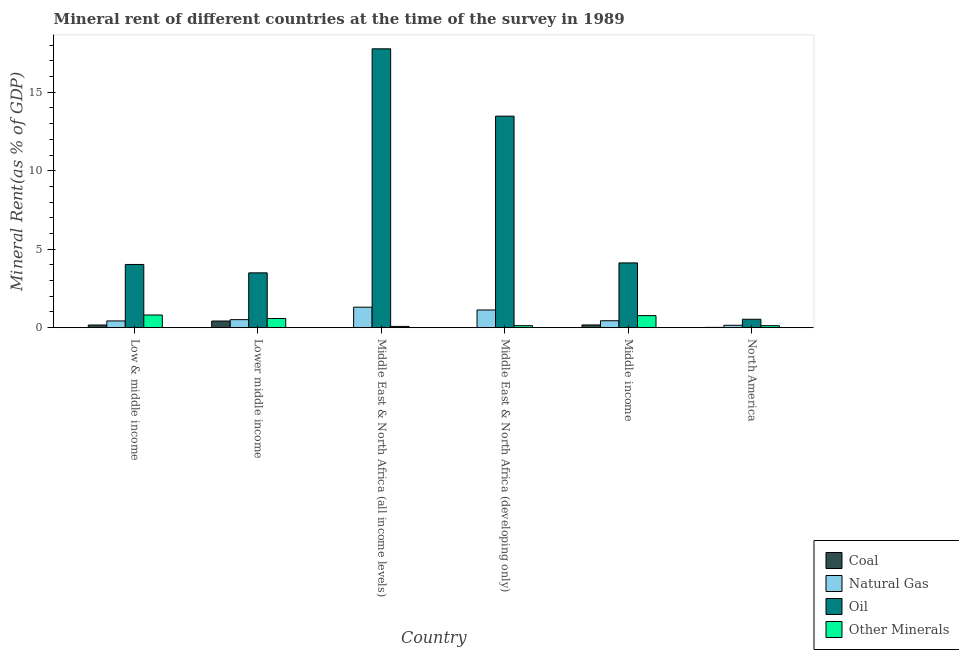Are the number of bars per tick equal to the number of legend labels?
Make the answer very short. Yes. Are the number of bars on each tick of the X-axis equal?
Make the answer very short. Yes. How many bars are there on the 6th tick from the left?
Your answer should be compact. 4. What is the label of the 2nd group of bars from the left?
Offer a very short reply. Lower middle income. In how many cases, is the number of bars for a given country not equal to the number of legend labels?
Offer a terse response. 0. What is the  rent of other minerals in North America?
Make the answer very short. 0.13. Across all countries, what is the maximum  rent of other minerals?
Ensure brevity in your answer.  0.81. Across all countries, what is the minimum  rent of other minerals?
Your answer should be compact. 0.08. In which country was the coal rent maximum?
Your answer should be very brief. Lower middle income. In which country was the coal rent minimum?
Your response must be concise. Middle East & North Africa (all income levels). What is the total  rent of other minerals in the graph?
Offer a very short reply. 2.49. What is the difference between the natural gas rent in Lower middle income and that in North America?
Ensure brevity in your answer.  0.36. What is the difference between the natural gas rent in Middle East & North Africa (developing only) and the  rent of other minerals in Low & middle income?
Give a very brief answer. 0.32. What is the average coal rent per country?
Keep it short and to the point. 0.13. What is the difference between the oil rent and  rent of other minerals in Lower middle income?
Provide a short and direct response. 2.91. In how many countries, is the oil rent greater than 14 %?
Keep it short and to the point. 1. What is the ratio of the  rent of other minerals in Middle East & North Africa (developing only) to that in North America?
Give a very brief answer. 0.99. Is the coal rent in Lower middle income less than that in Middle East & North Africa (developing only)?
Offer a terse response. No. Is the difference between the natural gas rent in Low & middle income and Middle East & North Africa (all income levels) greater than the difference between the  rent of other minerals in Low & middle income and Middle East & North Africa (all income levels)?
Provide a short and direct response. No. What is the difference between the highest and the second highest natural gas rent?
Your answer should be very brief. 0.18. What is the difference between the highest and the lowest natural gas rent?
Your response must be concise. 1.15. Is the sum of the oil rent in Low & middle income and Middle East & North Africa (developing only) greater than the maximum  rent of other minerals across all countries?
Your answer should be very brief. Yes. What does the 1st bar from the left in Middle income represents?
Your answer should be very brief. Coal. What does the 1st bar from the right in Low & middle income represents?
Your response must be concise. Other Minerals. Are all the bars in the graph horizontal?
Offer a terse response. No. How many countries are there in the graph?
Your response must be concise. 6. Does the graph contain any zero values?
Give a very brief answer. No. Where does the legend appear in the graph?
Your response must be concise. Bottom right. How many legend labels are there?
Offer a terse response. 4. What is the title of the graph?
Give a very brief answer. Mineral rent of different countries at the time of the survey in 1989. What is the label or title of the X-axis?
Provide a short and direct response. Country. What is the label or title of the Y-axis?
Offer a terse response. Mineral Rent(as % of GDP). What is the Mineral Rent(as % of GDP) in Coal in Low & middle income?
Provide a succinct answer. 0.17. What is the Mineral Rent(as % of GDP) in Natural Gas in Low & middle income?
Provide a short and direct response. 0.43. What is the Mineral Rent(as % of GDP) of Oil in Low & middle income?
Your response must be concise. 4.03. What is the Mineral Rent(as % of GDP) in Other Minerals in Low & middle income?
Make the answer very short. 0.81. What is the Mineral Rent(as % of GDP) of Coal in Lower middle income?
Provide a succinct answer. 0.42. What is the Mineral Rent(as % of GDP) in Natural Gas in Lower middle income?
Make the answer very short. 0.51. What is the Mineral Rent(as % of GDP) of Oil in Lower middle income?
Offer a terse response. 3.49. What is the Mineral Rent(as % of GDP) of Other Minerals in Lower middle income?
Ensure brevity in your answer.  0.58. What is the Mineral Rent(as % of GDP) in Coal in Middle East & North Africa (all income levels)?
Your response must be concise. 0. What is the Mineral Rent(as % of GDP) in Natural Gas in Middle East & North Africa (all income levels)?
Keep it short and to the point. 1.31. What is the Mineral Rent(as % of GDP) of Oil in Middle East & North Africa (all income levels)?
Keep it short and to the point. 17.77. What is the Mineral Rent(as % of GDP) of Other Minerals in Middle East & North Africa (all income levels)?
Make the answer very short. 0.08. What is the Mineral Rent(as % of GDP) of Coal in Middle East & North Africa (developing only)?
Offer a terse response. 0. What is the Mineral Rent(as % of GDP) in Natural Gas in Middle East & North Africa (developing only)?
Give a very brief answer. 1.13. What is the Mineral Rent(as % of GDP) in Oil in Middle East & North Africa (developing only)?
Make the answer very short. 13.48. What is the Mineral Rent(as % of GDP) of Other Minerals in Middle East & North Africa (developing only)?
Offer a very short reply. 0.13. What is the Mineral Rent(as % of GDP) of Coal in Middle income?
Your answer should be compact. 0.17. What is the Mineral Rent(as % of GDP) in Natural Gas in Middle income?
Provide a succinct answer. 0.44. What is the Mineral Rent(as % of GDP) of Oil in Middle income?
Your answer should be compact. 4.13. What is the Mineral Rent(as % of GDP) of Other Minerals in Middle income?
Keep it short and to the point. 0.77. What is the Mineral Rent(as % of GDP) in Coal in North America?
Your answer should be compact. 0.02. What is the Mineral Rent(as % of GDP) of Natural Gas in North America?
Offer a terse response. 0.15. What is the Mineral Rent(as % of GDP) in Oil in North America?
Keep it short and to the point. 0.54. What is the Mineral Rent(as % of GDP) of Other Minerals in North America?
Give a very brief answer. 0.13. Across all countries, what is the maximum Mineral Rent(as % of GDP) of Coal?
Your answer should be compact. 0.42. Across all countries, what is the maximum Mineral Rent(as % of GDP) in Natural Gas?
Make the answer very short. 1.31. Across all countries, what is the maximum Mineral Rent(as % of GDP) in Oil?
Provide a short and direct response. 17.77. Across all countries, what is the maximum Mineral Rent(as % of GDP) of Other Minerals?
Make the answer very short. 0.81. Across all countries, what is the minimum Mineral Rent(as % of GDP) in Coal?
Keep it short and to the point. 0. Across all countries, what is the minimum Mineral Rent(as % of GDP) of Natural Gas?
Your answer should be compact. 0.15. Across all countries, what is the minimum Mineral Rent(as % of GDP) in Oil?
Offer a very short reply. 0.54. Across all countries, what is the minimum Mineral Rent(as % of GDP) of Other Minerals?
Provide a succinct answer. 0.08. What is the total Mineral Rent(as % of GDP) in Coal in the graph?
Keep it short and to the point. 0.79. What is the total Mineral Rent(as % of GDP) in Natural Gas in the graph?
Provide a short and direct response. 3.96. What is the total Mineral Rent(as % of GDP) of Oil in the graph?
Your response must be concise. 43.43. What is the total Mineral Rent(as % of GDP) in Other Minerals in the graph?
Give a very brief answer. 2.49. What is the difference between the Mineral Rent(as % of GDP) in Coal in Low & middle income and that in Lower middle income?
Give a very brief answer. -0.25. What is the difference between the Mineral Rent(as % of GDP) of Natural Gas in Low & middle income and that in Lower middle income?
Make the answer very short. -0.08. What is the difference between the Mineral Rent(as % of GDP) of Oil in Low & middle income and that in Lower middle income?
Your response must be concise. 0.53. What is the difference between the Mineral Rent(as % of GDP) of Other Minerals in Low & middle income and that in Lower middle income?
Give a very brief answer. 0.22. What is the difference between the Mineral Rent(as % of GDP) of Coal in Low & middle income and that in Middle East & North Africa (all income levels)?
Offer a terse response. 0.17. What is the difference between the Mineral Rent(as % of GDP) of Natural Gas in Low & middle income and that in Middle East & North Africa (all income levels)?
Provide a succinct answer. -0.88. What is the difference between the Mineral Rent(as % of GDP) in Oil in Low & middle income and that in Middle East & North Africa (all income levels)?
Offer a very short reply. -13.74. What is the difference between the Mineral Rent(as % of GDP) of Other Minerals in Low & middle income and that in Middle East & North Africa (all income levels)?
Keep it short and to the point. 0.73. What is the difference between the Mineral Rent(as % of GDP) in Coal in Low & middle income and that in Middle East & North Africa (developing only)?
Provide a succinct answer. 0.17. What is the difference between the Mineral Rent(as % of GDP) of Natural Gas in Low & middle income and that in Middle East & North Africa (developing only)?
Keep it short and to the point. -0.7. What is the difference between the Mineral Rent(as % of GDP) in Oil in Low & middle income and that in Middle East & North Africa (developing only)?
Offer a very short reply. -9.45. What is the difference between the Mineral Rent(as % of GDP) of Other Minerals in Low & middle income and that in Middle East & North Africa (developing only)?
Your answer should be compact. 0.68. What is the difference between the Mineral Rent(as % of GDP) in Coal in Low & middle income and that in Middle income?
Provide a short and direct response. -0. What is the difference between the Mineral Rent(as % of GDP) of Natural Gas in Low & middle income and that in Middle income?
Provide a succinct answer. -0.01. What is the difference between the Mineral Rent(as % of GDP) in Oil in Low & middle income and that in Middle income?
Provide a short and direct response. -0.1. What is the difference between the Mineral Rent(as % of GDP) in Other Minerals in Low & middle income and that in Middle income?
Provide a succinct answer. 0.04. What is the difference between the Mineral Rent(as % of GDP) in Coal in Low & middle income and that in North America?
Keep it short and to the point. 0.15. What is the difference between the Mineral Rent(as % of GDP) of Natural Gas in Low & middle income and that in North America?
Your response must be concise. 0.28. What is the difference between the Mineral Rent(as % of GDP) in Oil in Low & middle income and that in North America?
Offer a terse response. 3.49. What is the difference between the Mineral Rent(as % of GDP) of Other Minerals in Low & middle income and that in North America?
Your response must be concise. 0.68. What is the difference between the Mineral Rent(as % of GDP) of Coal in Lower middle income and that in Middle East & North Africa (all income levels)?
Keep it short and to the point. 0.42. What is the difference between the Mineral Rent(as % of GDP) of Natural Gas in Lower middle income and that in Middle East & North Africa (all income levels)?
Offer a terse response. -0.79. What is the difference between the Mineral Rent(as % of GDP) in Oil in Lower middle income and that in Middle East & North Africa (all income levels)?
Your answer should be very brief. -14.28. What is the difference between the Mineral Rent(as % of GDP) of Other Minerals in Lower middle income and that in Middle East & North Africa (all income levels)?
Make the answer very short. 0.51. What is the difference between the Mineral Rent(as % of GDP) in Coal in Lower middle income and that in Middle East & North Africa (developing only)?
Offer a very short reply. 0.42. What is the difference between the Mineral Rent(as % of GDP) in Natural Gas in Lower middle income and that in Middle East & North Africa (developing only)?
Your answer should be compact. -0.62. What is the difference between the Mineral Rent(as % of GDP) of Oil in Lower middle income and that in Middle East & North Africa (developing only)?
Make the answer very short. -9.99. What is the difference between the Mineral Rent(as % of GDP) in Other Minerals in Lower middle income and that in Middle East & North Africa (developing only)?
Offer a very short reply. 0.46. What is the difference between the Mineral Rent(as % of GDP) of Coal in Lower middle income and that in Middle income?
Keep it short and to the point. 0.25. What is the difference between the Mineral Rent(as % of GDP) in Natural Gas in Lower middle income and that in Middle income?
Your answer should be compact. 0.07. What is the difference between the Mineral Rent(as % of GDP) in Oil in Lower middle income and that in Middle income?
Your response must be concise. -0.63. What is the difference between the Mineral Rent(as % of GDP) of Other Minerals in Lower middle income and that in Middle income?
Give a very brief answer. -0.18. What is the difference between the Mineral Rent(as % of GDP) of Coal in Lower middle income and that in North America?
Give a very brief answer. 0.41. What is the difference between the Mineral Rent(as % of GDP) in Natural Gas in Lower middle income and that in North America?
Ensure brevity in your answer.  0.36. What is the difference between the Mineral Rent(as % of GDP) of Oil in Lower middle income and that in North America?
Ensure brevity in your answer.  2.96. What is the difference between the Mineral Rent(as % of GDP) in Other Minerals in Lower middle income and that in North America?
Make the answer very short. 0.46. What is the difference between the Mineral Rent(as % of GDP) of Coal in Middle East & North Africa (all income levels) and that in Middle East & North Africa (developing only)?
Your answer should be very brief. -0. What is the difference between the Mineral Rent(as % of GDP) in Natural Gas in Middle East & North Africa (all income levels) and that in Middle East & North Africa (developing only)?
Give a very brief answer. 0.18. What is the difference between the Mineral Rent(as % of GDP) in Oil in Middle East & North Africa (all income levels) and that in Middle East & North Africa (developing only)?
Make the answer very short. 4.29. What is the difference between the Mineral Rent(as % of GDP) of Other Minerals in Middle East & North Africa (all income levels) and that in Middle East & North Africa (developing only)?
Provide a short and direct response. -0.05. What is the difference between the Mineral Rent(as % of GDP) in Coal in Middle East & North Africa (all income levels) and that in Middle income?
Provide a short and direct response. -0.17. What is the difference between the Mineral Rent(as % of GDP) of Natural Gas in Middle East & North Africa (all income levels) and that in Middle income?
Your response must be concise. 0.86. What is the difference between the Mineral Rent(as % of GDP) of Oil in Middle East & North Africa (all income levels) and that in Middle income?
Your answer should be very brief. 13.64. What is the difference between the Mineral Rent(as % of GDP) of Other Minerals in Middle East & North Africa (all income levels) and that in Middle income?
Keep it short and to the point. -0.69. What is the difference between the Mineral Rent(as % of GDP) of Coal in Middle East & North Africa (all income levels) and that in North America?
Provide a succinct answer. -0.02. What is the difference between the Mineral Rent(as % of GDP) of Natural Gas in Middle East & North Africa (all income levels) and that in North America?
Provide a short and direct response. 1.15. What is the difference between the Mineral Rent(as % of GDP) of Oil in Middle East & North Africa (all income levels) and that in North America?
Keep it short and to the point. 17.23. What is the difference between the Mineral Rent(as % of GDP) in Other Minerals in Middle East & North Africa (all income levels) and that in North America?
Give a very brief answer. -0.05. What is the difference between the Mineral Rent(as % of GDP) in Coal in Middle East & North Africa (developing only) and that in Middle income?
Ensure brevity in your answer.  -0.17. What is the difference between the Mineral Rent(as % of GDP) in Natural Gas in Middle East & North Africa (developing only) and that in Middle income?
Your response must be concise. 0.69. What is the difference between the Mineral Rent(as % of GDP) of Oil in Middle East & North Africa (developing only) and that in Middle income?
Offer a very short reply. 9.35. What is the difference between the Mineral Rent(as % of GDP) of Other Minerals in Middle East & North Africa (developing only) and that in Middle income?
Give a very brief answer. -0.64. What is the difference between the Mineral Rent(as % of GDP) in Coal in Middle East & North Africa (developing only) and that in North America?
Provide a succinct answer. -0.01. What is the difference between the Mineral Rent(as % of GDP) in Natural Gas in Middle East & North Africa (developing only) and that in North America?
Keep it short and to the point. 0.97. What is the difference between the Mineral Rent(as % of GDP) of Oil in Middle East & North Africa (developing only) and that in North America?
Provide a short and direct response. 12.94. What is the difference between the Mineral Rent(as % of GDP) in Other Minerals in Middle East & North Africa (developing only) and that in North America?
Your response must be concise. -0. What is the difference between the Mineral Rent(as % of GDP) of Coal in Middle income and that in North America?
Make the answer very short. 0.16. What is the difference between the Mineral Rent(as % of GDP) of Natural Gas in Middle income and that in North America?
Provide a succinct answer. 0.29. What is the difference between the Mineral Rent(as % of GDP) in Oil in Middle income and that in North America?
Offer a very short reply. 3.59. What is the difference between the Mineral Rent(as % of GDP) of Other Minerals in Middle income and that in North America?
Keep it short and to the point. 0.64. What is the difference between the Mineral Rent(as % of GDP) in Coal in Low & middle income and the Mineral Rent(as % of GDP) in Natural Gas in Lower middle income?
Your answer should be compact. -0.34. What is the difference between the Mineral Rent(as % of GDP) of Coal in Low & middle income and the Mineral Rent(as % of GDP) of Oil in Lower middle income?
Provide a short and direct response. -3.32. What is the difference between the Mineral Rent(as % of GDP) in Coal in Low & middle income and the Mineral Rent(as % of GDP) in Other Minerals in Lower middle income?
Offer a very short reply. -0.42. What is the difference between the Mineral Rent(as % of GDP) of Natural Gas in Low & middle income and the Mineral Rent(as % of GDP) of Oil in Lower middle income?
Keep it short and to the point. -3.06. What is the difference between the Mineral Rent(as % of GDP) of Natural Gas in Low & middle income and the Mineral Rent(as % of GDP) of Other Minerals in Lower middle income?
Offer a very short reply. -0.16. What is the difference between the Mineral Rent(as % of GDP) in Oil in Low & middle income and the Mineral Rent(as % of GDP) in Other Minerals in Lower middle income?
Keep it short and to the point. 3.44. What is the difference between the Mineral Rent(as % of GDP) in Coal in Low & middle income and the Mineral Rent(as % of GDP) in Natural Gas in Middle East & North Africa (all income levels)?
Your response must be concise. -1.14. What is the difference between the Mineral Rent(as % of GDP) of Coal in Low & middle income and the Mineral Rent(as % of GDP) of Oil in Middle East & North Africa (all income levels)?
Your answer should be very brief. -17.6. What is the difference between the Mineral Rent(as % of GDP) in Coal in Low & middle income and the Mineral Rent(as % of GDP) in Other Minerals in Middle East & North Africa (all income levels)?
Provide a succinct answer. 0.09. What is the difference between the Mineral Rent(as % of GDP) of Natural Gas in Low & middle income and the Mineral Rent(as % of GDP) of Oil in Middle East & North Africa (all income levels)?
Provide a succinct answer. -17.34. What is the difference between the Mineral Rent(as % of GDP) of Natural Gas in Low & middle income and the Mineral Rent(as % of GDP) of Other Minerals in Middle East & North Africa (all income levels)?
Your response must be concise. 0.35. What is the difference between the Mineral Rent(as % of GDP) of Oil in Low & middle income and the Mineral Rent(as % of GDP) of Other Minerals in Middle East & North Africa (all income levels)?
Provide a succinct answer. 3.95. What is the difference between the Mineral Rent(as % of GDP) in Coal in Low & middle income and the Mineral Rent(as % of GDP) in Natural Gas in Middle East & North Africa (developing only)?
Give a very brief answer. -0.96. What is the difference between the Mineral Rent(as % of GDP) of Coal in Low & middle income and the Mineral Rent(as % of GDP) of Oil in Middle East & North Africa (developing only)?
Provide a short and direct response. -13.31. What is the difference between the Mineral Rent(as % of GDP) in Coal in Low & middle income and the Mineral Rent(as % of GDP) in Other Minerals in Middle East & North Africa (developing only)?
Provide a succinct answer. 0.04. What is the difference between the Mineral Rent(as % of GDP) in Natural Gas in Low & middle income and the Mineral Rent(as % of GDP) in Oil in Middle East & North Africa (developing only)?
Your answer should be very brief. -13.05. What is the difference between the Mineral Rent(as % of GDP) in Natural Gas in Low & middle income and the Mineral Rent(as % of GDP) in Other Minerals in Middle East & North Africa (developing only)?
Your answer should be very brief. 0.3. What is the difference between the Mineral Rent(as % of GDP) of Oil in Low & middle income and the Mineral Rent(as % of GDP) of Other Minerals in Middle East & North Africa (developing only)?
Your answer should be very brief. 3.9. What is the difference between the Mineral Rent(as % of GDP) of Coal in Low & middle income and the Mineral Rent(as % of GDP) of Natural Gas in Middle income?
Offer a terse response. -0.27. What is the difference between the Mineral Rent(as % of GDP) in Coal in Low & middle income and the Mineral Rent(as % of GDP) in Oil in Middle income?
Your response must be concise. -3.96. What is the difference between the Mineral Rent(as % of GDP) of Coal in Low & middle income and the Mineral Rent(as % of GDP) of Other Minerals in Middle income?
Your answer should be very brief. -0.6. What is the difference between the Mineral Rent(as % of GDP) of Natural Gas in Low & middle income and the Mineral Rent(as % of GDP) of Oil in Middle income?
Keep it short and to the point. -3.7. What is the difference between the Mineral Rent(as % of GDP) of Natural Gas in Low & middle income and the Mineral Rent(as % of GDP) of Other Minerals in Middle income?
Offer a terse response. -0.34. What is the difference between the Mineral Rent(as % of GDP) of Oil in Low & middle income and the Mineral Rent(as % of GDP) of Other Minerals in Middle income?
Offer a very short reply. 3.26. What is the difference between the Mineral Rent(as % of GDP) of Coal in Low & middle income and the Mineral Rent(as % of GDP) of Natural Gas in North America?
Your answer should be very brief. 0.02. What is the difference between the Mineral Rent(as % of GDP) of Coal in Low & middle income and the Mineral Rent(as % of GDP) of Oil in North America?
Provide a short and direct response. -0.37. What is the difference between the Mineral Rent(as % of GDP) in Coal in Low & middle income and the Mineral Rent(as % of GDP) in Other Minerals in North America?
Your response must be concise. 0.04. What is the difference between the Mineral Rent(as % of GDP) in Natural Gas in Low & middle income and the Mineral Rent(as % of GDP) in Oil in North America?
Your answer should be very brief. -0.11. What is the difference between the Mineral Rent(as % of GDP) in Natural Gas in Low & middle income and the Mineral Rent(as % of GDP) in Other Minerals in North America?
Provide a short and direct response. 0.3. What is the difference between the Mineral Rent(as % of GDP) in Oil in Low & middle income and the Mineral Rent(as % of GDP) in Other Minerals in North America?
Provide a succinct answer. 3.9. What is the difference between the Mineral Rent(as % of GDP) of Coal in Lower middle income and the Mineral Rent(as % of GDP) of Natural Gas in Middle East & North Africa (all income levels)?
Your answer should be compact. -0.88. What is the difference between the Mineral Rent(as % of GDP) of Coal in Lower middle income and the Mineral Rent(as % of GDP) of Oil in Middle East & North Africa (all income levels)?
Offer a terse response. -17.35. What is the difference between the Mineral Rent(as % of GDP) in Coal in Lower middle income and the Mineral Rent(as % of GDP) in Other Minerals in Middle East & North Africa (all income levels)?
Give a very brief answer. 0.34. What is the difference between the Mineral Rent(as % of GDP) of Natural Gas in Lower middle income and the Mineral Rent(as % of GDP) of Oil in Middle East & North Africa (all income levels)?
Make the answer very short. -17.26. What is the difference between the Mineral Rent(as % of GDP) of Natural Gas in Lower middle income and the Mineral Rent(as % of GDP) of Other Minerals in Middle East & North Africa (all income levels)?
Give a very brief answer. 0.43. What is the difference between the Mineral Rent(as % of GDP) of Oil in Lower middle income and the Mineral Rent(as % of GDP) of Other Minerals in Middle East & North Africa (all income levels)?
Offer a very short reply. 3.41. What is the difference between the Mineral Rent(as % of GDP) in Coal in Lower middle income and the Mineral Rent(as % of GDP) in Natural Gas in Middle East & North Africa (developing only)?
Provide a succinct answer. -0.7. What is the difference between the Mineral Rent(as % of GDP) of Coal in Lower middle income and the Mineral Rent(as % of GDP) of Oil in Middle East & North Africa (developing only)?
Keep it short and to the point. -13.06. What is the difference between the Mineral Rent(as % of GDP) of Coal in Lower middle income and the Mineral Rent(as % of GDP) of Other Minerals in Middle East & North Africa (developing only)?
Your answer should be compact. 0.3. What is the difference between the Mineral Rent(as % of GDP) in Natural Gas in Lower middle income and the Mineral Rent(as % of GDP) in Oil in Middle East & North Africa (developing only)?
Offer a terse response. -12.97. What is the difference between the Mineral Rent(as % of GDP) of Natural Gas in Lower middle income and the Mineral Rent(as % of GDP) of Other Minerals in Middle East & North Africa (developing only)?
Offer a very short reply. 0.39. What is the difference between the Mineral Rent(as % of GDP) in Oil in Lower middle income and the Mineral Rent(as % of GDP) in Other Minerals in Middle East & North Africa (developing only)?
Offer a terse response. 3.37. What is the difference between the Mineral Rent(as % of GDP) of Coal in Lower middle income and the Mineral Rent(as % of GDP) of Natural Gas in Middle income?
Give a very brief answer. -0.02. What is the difference between the Mineral Rent(as % of GDP) of Coal in Lower middle income and the Mineral Rent(as % of GDP) of Oil in Middle income?
Your answer should be very brief. -3.7. What is the difference between the Mineral Rent(as % of GDP) of Coal in Lower middle income and the Mineral Rent(as % of GDP) of Other Minerals in Middle income?
Make the answer very short. -0.34. What is the difference between the Mineral Rent(as % of GDP) of Natural Gas in Lower middle income and the Mineral Rent(as % of GDP) of Oil in Middle income?
Offer a terse response. -3.62. What is the difference between the Mineral Rent(as % of GDP) of Natural Gas in Lower middle income and the Mineral Rent(as % of GDP) of Other Minerals in Middle income?
Offer a very short reply. -0.26. What is the difference between the Mineral Rent(as % of GDP) of Oil in Lower middle income and the Mineral Rent(as % of GDP) of Other Minerals in Middle income?
Your answer should be very brief. 2.73. What is the difference between the Mineral Rent(as % of GDP) in Coal in Lower middle income and the Mineral Rent(as % of GDP) in Natural Gas in North America?
Keep it short and to the point. 0.27. What is the difference between the Mineral Rent(as % of GDP) in Coal in Lower middle income and the Mineral Rent(as % of GDP) in Oil in North America?
Offer a terse response. -0.11. What is the difference between the Mineral Rent(as % of GDP) in Coal in Lower middle income and the Mineral Rent(as % of GDP) in Other Minerals in North America?
Ensure brevity in your answer.  0.3. What is the difference between the Mineral Rent(as % of GDP) of Natural Gas in Lower middle income and the Mineral Rent(as % of GDP) of Oil in North America?
Your response must be concise. -0.03. What is the difference between the Mineral Rent(as % of GDP) in Natural Gas in Lower middle income and the Mineral Rent(as % of GDP) in Other Minerals in North America?
Ensure brevity in your answer.  0.38. What is the difference between the Mineral Rent(as % of GDP) in Oil in Lower middle income and the Mineral Rent(as % of GDP) in Other Minerals in North America?
Provide a succinct answer. 3.37. What is the difference between the Mineral Rent(as % of GDP) of Coal in Middle East & North Africa (all income levels) and the Mineral Rent(as % of GDP) of Natural Gas in Middle East & North Africa (developing only)?
Make the answer very short. -1.13. What is the difference between the Mineral Rent(as % of GDP) in Coal in Middle East & North Africa (all income levels) and the Mineral Rent(as % of GDP) in Oil in Middle East & North Africa (developing only)?
Offer a very short reply. -13.48. What is the difference between the Mineral Rent(as % of GDP) in Coal in Middle East & North Africa (all income levels) and the Mineral Rent(as % of GDP) in Other Minerals in Middle East & North Africa (developing only)?
Your answer should be compact. -0.12. What is the difference between the Mineral Rent(as % of GDP) of Natural Gas in Middle East & North Africa (all income levels) and the Mineral Rent(as % of GDP) of Oil in Middle East & North Africa (developing only)?
Keep it short and to the point. -12.17. What is the difference between the Mineral Rent(as % of GDP) of Natural Gas in Middle East & North Africa (all income levels) and the Mineral Rent(as % of GDP) of Other Minerals in Middle East & North Africa (developing only)?
Give a very brief answer. 1.18. What is the difference between the Mineral Rent(as % of GDP) of Oil in Middle East & North Africa (all income levels) and the Mineral Rent(as % of GDP) of Other Minerals in Middle East & North Africa (developing only)?
Provide a short and direct response. 17.64. What is the difference between the Mineral Rent(as % of GDP) in Coal in Middle East & North Africa (all income levels) and the Mineral Rent(as % of GDP) in Natural Gas in Middle income?
Your answer should be very brief. -0.44. What is the difference between the Mineral Rent(as % of GDP) of Coal in Middle East & North Africa (all income levels) and the Mineral Rent(as % of GDP) of Oil in Middle income?
Ensure brevity in your answer.  -4.12. What is the difference between the Mineral Rent(as % of GDP) in Coal in Middle East & North Africa (all income levels) and the Mineral Rent(as % of GDP) in Other Minerals in Middle income?
Provide a succinct answer. -0.77. What is the difference between the Mineral Rent(as % of GDP) of Natural Gas in Middle East & North Africa (all income levels) and the Mineral Rent(as % of GDP) of Oil in Middle income?
Your answer should be compact. -2.82. What is the difference between the Mineral Rent(as % of GDP) of Natural Gas in Middle East & North Africa (all income levels) and the Mineral Rent(as % of GDP) of Other Minerals in Middle income?
Your answer should be very brief. 0.54. What is the difference between the Mineral Rent(as % of GDP) in Oil in Middle East & North Africa (all income levels) and the Mineral Rent(as % of GDP) in Other Minerals in Middle income?
Make the answer very short. 17. What is the difference between the Mineral Rent(as % of GDP) of Coal in Middle East & North Africa (all income levels) and the Mineral Rent(as % of GDP) of Natural Gas in North America?
Offer a terse response. -0.15. What is the difference between the Mineral Rent(as % of GDP) in Coal in Middle East & North Africa (all income levels) and the Mineral Rent(as % of GDP) in Oil in North America?
Your response must be concise. -0.53. What is the difference between the Mineral Rent(as % of GDP) of Coal in Middle East & North Africa (all income levels) and the Mineral Rent(as % of GDP) of Other Minerals in North America?
Provide a short and direct response. -0.12. What is the difference between the Mineral Rent(as % of GDP) of Natural Gas in Middle East & North Africa (all income levels) and the Mineral Rent(as % of GDP) of Oil in North America?
Keep it short and to the point. 0.77. What is the difference between the Mineral Rent(as % of GDP) of Natural Gas in Middle East & North Africa (all income levels) and the Mineral Rent(as % of GDP) of Other Minerals in North America?
Offer a very short reply. 1.18. What is the difference between the Mineral Rent(as % of GDP) of Oil in Middle East & North Africa (all income levels) and the Mineral Rent(as % of GDP) of Other Minerals in North America?
Provide a succinct answer. 17.64. What is the difference between the Mineral Rent(as % of GDP) of Coal in Middle East & North Africa (developing only) and the Mineral Rent(as % of GDP) of Natural Gas in Middle income?
Provide a short and direct response. -0.44. What is the difference between the Mineral Rent(as % of GDP) in Coal in Middle East & North Africa (developing only) and the Mineral Rent(as % of GDP) in Oil in Middle income?
Give a very brief answer. -4.12. What is the difference between the Mineral Rent(as % of GDP) of Coal in Middle East & North Africa (developing only) and the Mineral Rent(as % of GDP) of Other Minerals in Middle income?
Give a very brief answer. -0.76. What is the difference between the Mineral Rent(as % of GDP) of Natural Gas in Middle East & North Africa (developing only) and the Mineral Rent(as % of GDP) of Oil in Middle income?
Ensure brevity in your answer.  -3. What is the difference between the Mineral Rent(as % of GDP) in Natural Gas in Middle East & North Africa (developing only) and the Mineral Rent(as % of GDP) in Other Minerals in Middle income?
Make the answer very short. 0.36. What is the difference between the Mineral Rent(as % of GDP) of Oil in Middle East & North Africa (developing only) and the Mineral Rent(as % of GDP) of Other Minerals in Middle income?
Provide a short and direct response. 12.71. What is the difference between the Mineral Rent(as % of GDP) in Coal in Middle East & North Africa (developing only) and the Mineral Rent(as % of GDP) in Natural Gas in North America?
Make the answer very short. -0.15. What is the difference between the Mineral Rent(as % of GDP) in Coal in Middle East & North Africa (developing only) and the Mineral Rent(as % of GDP) in Oil in North America?
Your answer should be very brief. -0.53. What is the difference between the Mineral Rent(as % of GDP) of Coal in Middle East & North Africa (developing only) and the Mineral Rent(as % of GDP) of Other Minerals in North America?
Offer a very short reply. -0.12. What is the difference between the Mineral Rent(as % of GDP) in Natural Gas in Middle East & North Africa (developing only) and the Mineral Rent(as % of GDP) in Oil in North America?
Offer a terse response. 0.59. What is the difference between the Mineral Rent(as % of GDP) of Natural Gas in Middle East & North Africa (developing only) and the Mineral Rent(as % of GDP) of Other Minerals in North America?
Provide a short and direct response. 1. What is the difference between the Mineral Rent(as % of GDP) of Oil in Middle East & North Africa (developing only) and the Mineral Rent(as % of GDP) of Other Minerals in North America?
Your answer should be compact. 13.35. What is the difference between the Mineral Rent(as % of GDP) in Coal in Middle income and the Mineral Rent(as % of GDP) in Natural Gas in North America?
Your answer should be very brief. 0.02. What is the difference between the Mineral Rent(as % of GDP) of Coal in Middle income and the Mineral Rent(as % of GDP) of Oil in North America?
Give a very brief answer. -0.36. What is the difference between the Mineral Rent(as % of GDP) of Coal in Middle income and the Mineral Rent(as % of GDP) of Other Minerals in North America?
Your answer should be compact. 0.05. What is the difference between the Mineral Rent(as % of GDP) in Natural Gas in Middle income and the Mineral Rent(as % of GDP) in Oil in North America?
Your response must be concise. -0.1. What is the difference between the Mineral Rent(as % of GDP) in Natural Gas in Middle income and the Mineral Rent(as % of GDP) in Other Minerals in North America?
Ensure brevity in your answer.  0.31. What is the difference between the Mineral Rent(as % of GDP) of Oil in Middle income and the Mineral Rent(as % of GDP) of Other Minerals in North America?
Offer a very short reply. 4. What is the average Mineral Rent(as % of GDP) of Coal per country?
Make the answer very short. 0.13. What is the average Mineral Rent(as % of GDP) of Natural Gas per country?
Provide a succinct answer. 0.66. What is the average Mineral Rent(as % of GDP) in Oil per country?
Offer a very short reply. 7.24. What is the average Mineral Rent(as % of GDP) in Other Minerals per country?
Keep it short and to the point. 0.41. What is the difference between the Mineral Rent(as % of GDP) of Coal and Mineral Rent(as % of GDP) of Natural Gas in Low & middle income?
Your answer should be very brief. -0.26. What is the difference between the Mineral Rent(as % of GDP) of Coal and Mineral Rent(as % of GDP) of Oil in Low & middle income?
Ensure brevity in your answer.  -3.86. What is the difference between the Mineral Rent(as % of GDP) in Coal and Mineral Rent(as % of GDP) in Other Minerals in Low & middle income?
Provide a succinct answer. -0.64. What is the difference between the Mineral Rent(as % of GDP) in Natural Gas and Mineral Rent(as % of GDP) in Oil in Low & middle income?
Make the answer very short. -3.6. What is the difference between the Mineral Rent(as % of GDP) of Natural Gas and Mineral Rent(as % of GDP) of Other Minerals in Low & middle income?
Ensure brevity in your answer.  -0.38. What is the difference between the Mineral Rent(as % of GDP) in Oil and Mineral Rent(as % of GDP) in Other Minerals in Low & middle income?
Make the answer very short. 3.22. What is the difference between the Mineral Rent(as % of GDP) of Coal and Mineral Rent(as % of GDP) of Natural Gas in Lower middle income?
Ensure brevity in your answer.  -0.09. What is the difference between the Mineral Rent(as % of GDP) of Coal and Mineral Rent(as % of GDP) of Oil in Lower middle income?
Make the answer very short. -3.07. What is the difference between the Mineral Rent(as % of GDP) of Coal and Mineral Rent(as % of GDP) of Other Minerals in Lower middle income?
Offer a very short reply. -0.16. What is the difference between the Mineral Rent(as % of GDP) of Natural Gas and Mineral Rent(as % of GDP) of Oil in Lower middle income?
Offer a very short reply. -2.98. What is the difference between the Mineral Rent(as % of GDP) of Natural Gas and Mineral Rent(as % of GDP) of Other Minerals in Lower middle income?
Your answer should be very brief. -0.07. What is the difference between the Mineral Rent(as % of GDP) of Oil and Mineral Rent(as % of GDP) of Other Minerals in Lower middle income?
Provide a short and direct response. 2.91. What is the difference between the Mineral Rent(as % of GDP) of Coal and Mineral Rent(as % of GDP) of Natural Gas in Middle East & North Africa (all income levels)?
Make the answer very short. -1.3. What is the difference between the Mineral Rent(as % of GDP) in Coal and Mineral Rent(as % of GDP) in Oil in Middle East & North Africa (all income levels)?
Make the answer very short. -17.77. What is the difference between the Mineral Rent(as % of GDP) of Coal and Mineral Rent(as % of GDP) of Other Minerals in Middle East & North Africa (all income levels)?
Your answer should be compact. -0.08. What is the difference between the Mineral Rent(as % of GDP) in Natural Gas and Mineral Rent(as % of GDP) in Oil in Middle East & North Africa (all income levels)?
Ensure brevity in your answer.  -16.46. What is the difference between the Mineral Rent(as % of GDP) of Natural Gas and Mineral Rent(as % of GDP) of Other Minerals in Middle East & North Africa (all income levels)?
Keep it short and to the point. 1.23. What is the difference between the Mineral Rent(as % of GDP) of Oil and Mineral Rent(as % of GDP) of Other Minerals in Middle East & North Africa (all income levels)?
Your response must be concise. 17.69. What is the difference between the Mineral Rent(as % of GDP) in Coal and Mineral Rent(as % of GDP) in Natural Gas in Middle East & North Africa (developing only)?
Your response must be concise. -1.12. What is the difference between the Mineral Rent(as % of GDP) in Coal and Mineral Rent(as % of GDP) in Oil in Middle East & North Africa (developing only)?
Keep it short and to the point. -13.48. What is the difference between the Mineral Rent(as % of GDP) in Coal and Mineral Rent(as % of GDP) in Other Minerals in Middle East & North Africa (developing only)?
Offer a terse response. -0.12. What is the difference between the Mineral Rent(as % of GDP) of Natural Gas and Mineral Rent(as % of GDP) of Oil in Middle East & North Africa (developing only)?
Provide a succinct answer. -12.35. What is the difference between the Mineral Rent(as % of GDP) of Natural Gas and Mineral Rent(as % of GDP) of Other Minerals in Middle East & North Africa (developing only)?
Give a very brief answer. 1. What is the difference between the Mineral Rent(as % of GDP) of Oil and Mineral Rent(as % of GDP) of Other Minerals in Middle East & North Africa (developing only)?
Your answer should be compact. 13.35. What is the difference between the Mineral Rent(as % of GDP) in Coal and Mineral Rent(as % of GDP) in Natural Gas in Middle income?
Offer a very short reply. -0.27. What is the difference between the Mineral Rent(as % of GDP) in Coal and Mineral Rent(as % of GDP) in Oil in Middle income?
Offer a terse response. -3.95. What is the difference between the Mineral Rent(as % of GDP) of Coal and Mineral Rent(as % of GDP) of Other Minerals in Middle income?
Ensure brevity in your answer.  -0.59. What is the difference between the Mineral Rent(as % of GDP) in Natural Gas and Mineral Rent(as % of GDP) in Oil in Middle income?
Offer a very short reply. -3.69. What is the difference between the Mineral Rent(as % of GDP) in Natural Gas and Mineral Rent(as % of GDP) in Other Minerals in Middle income?
Make the answer very short. -0.33. What is the difference between the Mineral Rent(as % of GDP) in Oil and Mineral Rent(as % of GDP) in Other Minerals in Middle income?
Provide a succinct answer. 3.36. What is the difference between the Mineral Rent(as % of GDP) in Coal and Mineral Rent(as % of GDP) in Natural Gas in North America?
Make the answer very short. -0.13. What is the difference between the Mineral Rent(as % of GDP) of Coal and Mineral Rent(as % of GDP) of Oil in North America?
Give a very brief answer. -0.52. What is the difference between the Mineral Rent(as % of GDP) of Coal and Mineral Rent(as % of GDP) of Other Minerals in North America?
Keep it short and to the point. -0.11. What is the difference between the Mineral Rent(as % of GDP) of Natural Gas and Mineral Rent(as % of GDP) of Oil in North America?
Ensure brevity in your answer.  -0.38. What is the difference between the Mineral Rent(as % of GDP) of Natural Gas and Mineral Rent(as % of GDP) of Other Minerals in North America?
Offer a terse response. 0.03. What is the difference between the Mineral Rent(as % of GDP) in Oil and Mineral Rent(as % of GDP) in Other Minerals in North America?
Offer a very short reply. 0.41. What is the ratio of the Mineral Rent(as % of GDP) of Coal in Low & middle income to that in Lower middle income?
Your answer should be very brief. 0.4. What is the ratio of the Mineral Rent(as % of GDP) of Natural Gas in Low & middle income to that in Lower middle income?
Your answer should be compact. 0.84. What is the ratio of the Mineral Rent(as % of GDP) of Oil in Low & middle income to that in Lower middle income?
Provide a short and direct response. 1.15. What is the ratio of the Mineral Rent(as % of GDP) in Other Minerals in Low & middle income to that in Lower middle income?
Give a very brief answer. 1.38. What is the ratio of the Mineral Rent(as % of GDP) in Coal in Low & middle income to that in Middle East & North Africa (all income levels)?
Your answer should be very brief. 101.22. What is the ratio of the Mineral Rent(as % of GDP) in Natural Gas in Low & middle income to that in Middle East & North Africa (all income levels)?
Provide a succinct answer. 0.33. What is the ratio of the Mineral Rent(as % of GDP) of Oil in Low & middle income to that in Middle East & North Africa (all income levels)?
Give a very brief answer. 0.23. What is the ratio of the Mineral Rent(as % of GDP) in Other Minerals in Low & middle income to that in Middle East & North Africa (all income levels)?
Offer a terse response. 10.18. What is the ratio of the Mineral Rent(as % of GDP) of Coal in Low & middle income to that in Middle East & North Africa (developing only)?
Your answer should be very brief. 60.21. What is the ratio of the Mineral Rent(as % of GDP) of Natural Gas in Low & middle income to that in Middle East & North Africa (developing only)?
Your answer should be compact. 0.38. What is the ratio of the Mineral Rent(as % of GDP) in Oil in Low & middle income to that in Middle East & North Africa (developing only)?
Make the answer very short. 0.3. What is the ratio of the Mineral Rent(as % of GDP) of Other Minerals in Low & middle income to that in Middle East & North Africa (developing only)?
Your answer should be compact. 6.43. What is the ratio of the Mineral Rent(as % of GDP) in Coal in Low & middle income to that in Middle income?
Keep it short and to the point. 0.98. What is the ratio of the Mineral Rent(as % of GDP) in Natural Gas in Low & middle income to that in Middle income?
Provide a succinct answer. 0.97. What is the ratio of the Mineral Rent(as % of GDP) in Oil in Low & middle income to that in Middle income?
Keep it short and to the point. 0.98. What is the ratio of the Mineral Rent(as % of GDP) in Other Minerals in Low & middle income to that in Middle income?
Offer a terse response. 1.05. What is the ratio of the Mineral Rent(as % of GDP) in Coal in Low & middle income to that in North America?
Offer a terse response. 9.62. What is the ratio of the Mineral Rent(as % of GDP) in Natural Gas in Low & middle income to that in North America?
Offer a terse response. 2.82. What is the ratio of the Mineral Rent(as % of GDP) of Oil in Low & middle income to that in North America?
Give a very brief answer. 7.52. What is the ratio of the Mineral Rent(as % of GDP) of Other Minerals in Low & middle income to that in North America?
Your answer should be very brief. 6.38. What is the ratio of the Mineral Rent(as % of GDP) in Coal in Lower middle income to that in Middle East & North Africa (all income levels)?
Provide a short and direct response. 253.53. What is the ratio of the Mineral Rent(as % of GDP) of Natural Gas in Lower middle income to that in Middle East & North Africa (all income levels)?
Your answer should be very brief. 0.39. What is the ratio of the Mineral Rent(as % of GDP) of Oil in Lower middle income to that in Middle East & North Africa (all income levels)?
Ensure brevity in your answer.  0.2. What is the ratio of the Mineral Rent(as % of GDP) of Other Minerals in Lower middle income to that in Middle East & North Africa (all income levels)?
Offer a very short reply. 7.39. What is the ratio of the Mineral Rent(as % of GDP) in Coal in Lower middle income to that in Middle East & North Africa (developing only)?
Your response must be concise. 150.79. What is the ratio of the Mineral Rent(as % of GDP) of Natural Gas in Lower middle income to that in Middle East & North Africa (developing only)?
Your response must be concise. 0.45. What is the ratio of the Mineral Rent(as % of GDP) in Oil in Lower middle income to that in Middle East & North Africa (developing only)?
Your response must be concise. 0.26. What is the ratio of the Mineral Rent(as % of GDP) of Other Minerals in Lower middle income to that in Middle East & North Africa (developing only)?
Provide a short and direct response. 4.66. What is the ratio of the Mineral Rent(as % of GDP) in Coal in Lower middle income to that in Middle income?
Your response must be concise. 2.45. What is the ratio of the Mineral Rent(as % of GDP) of Natural Gas in Lower middle income to that in Middle income?
Your answer should be compact. 1.16. What is the ratio of the Mineral Rent(as % of GDP) in Oil in Lower middle income to that in Middle income?
Your answer should be compact. 0.85. What is the ratio of the Mineral Rent(as % of GDP) in Other Minerals in Lower middle income to that in Middle income?
Your answer should be very brief. 0.76. What is the ratio of the Mineral Rent(as % of GDP) of Coal in Lower middle income to that in North America?
Make the answer very short. 24.1. What is the ratio of the Mineral Rent(as % of GDP) of Natural Gas in Lower middle income to that in North America?
Your response must be concise. 3.36. What is the ratio of the Mineral Rent(as % of GDP) of Oil in Lower middle income to that in North America?
Your answer should be very brief. 6.52. What is the ratio of the Mineral Rent(as % of GDP) of Other Minerals in Lower middle income to that in North America?
Your answer should be very brief. 4.63. What is the ratio of the Mineral Rent(as % of GDP) in Coal in Middle East & North Africa (all income levels) to that in Middle East & North Africa (developing only)?
Give a very brief answer. 0.59. What is the ratio of the Mineral Rent(as % of GDP) of Natural Gas in Middle East & North Africa (all income levels) to that in Middle East & North Africa (developing only)?
Provide a succinct answer. 1.16. What is the ratio of the Mineral Rent(as % of GDP) of Oil in Middle East & North Africa (all income levels) to that in Middle East & North Africa (developing only)?
Keep it short and to the point. 1.32. What is the ratio of the Mineral Rent(as % of GDP) of Other Minerals in Middle East & North Africa (all income levels) to that in Middle East & North Africa (developing only)?
Provide a short and direct response. 0.63. What is the ratio of the Mineral Rent(as % of GDP) of Coal in Middle East & North Africa (all income levels) to that in Middle income?
Your answer should be compact. 0.01. What is the ratio of the Mineral Rent(as % of GDP) of Natural Gas in Middle East & North Africa (all income levels) to that in Middle income?
Make the answer very short. 2.96. What is the ratio of the Mineral Rent(as % of GDP) in Oil in Middle East & North Africa (all income levels) to that in Middle income?
Offer a terse response. 4.31. What is the ratio of the Mineral Rent(as % of GDP) in Other Minerals in Middle East & North Africa (all income levels) to that in Middle income?
Keep it short and to the point. 0.1. What is the ratio of the Mineral Rent(as % of GDP) in Coal in Middle East & North Africa (all income levels) to that in North America?
Ensure brevity in your answer.  0.1. What is the ratio of the Mineral Rent(as % of GDP) in Natural Gas in Middle East & North Africa (all income levels) to that in North America?
Offer a very short reply. 8.58. What is the ratio of the Mineral Rent(as % of GDP) in Oil in Middle East & North Africa (all income levels) to that in North America?
Make the answer very short. 33.17. What is the ratio of the Mineral Rent(as % of GDP) of Other Minerals in Middle East & North Africa (all income levels) to that in North America?
Your answer should be compact. 0.63. What is the ratio of the Mineral Rent(as % of GDP) in Coal in Middle East & North Africa (developing only) to that in Middle income?
Provide a short and direct response. 0.02. What is the ratio of the Mineral Rent(as % of GDP) in Natural Gas in Middle East & North Africa (developing only) to that in Middle income?
Keep it short and to the point. 2.56. What is the ratio of the Mineral Rent(as % of GDP) in Oil in Middle East & North Africa (developing only) to that in Middle income?
Give a very brief answer. 3.27. What is the ratio of the Mineral Rent(as % of GDP) in Other Minerals in Middle East & North Africa (developing only) to that in Middle income?
Keep it short and to the point. 0.16. What is the ratio of the Mineral Rent(as % of GDP) in Coal in Middle East & North Africa (developing only) to that in North America?
Ensure brevity in your answer.  0.16. What is the ratio of the Mineral Rent(as % of GDP) of Natural Gas in Middle East & North Africa (developing only) to that in North America?
Your answer should be compact. 7.41. What is the ratio of the Mineral Rent(as % of GDP) in Oil in Middle East & North Africa (developing only) to that in North America?
Make the answer very short. 25.16. What is the ratio of the Mineral Rent(as % of GDP) in Other Minerals in Middle East & North Africa (developing only) to that in North America?
Your answer should be very brief. 0.99. What is the ratio of the Mineral Rent(as % of GDP) of Coal in Middle income to that in North America?
Your answer should be compact. 9.85. What is the ratio of the Mineral Rent(as % of GDP) of Natural Gas in Middle income to that in North America?
Make the answer very short. 2.9. What is the ratio of the Mineral Rent(as % of GDP) of Oil in Middle income to that in North America?
Keep it short and to the point. 7.7. What is the ratio of the Mineral Rent(as % of GDP) of Other Minerals in Middle income to that in North America?
Ensure brevity in your answer.  6.07. What is the difference between the highest and the second highest Mineral Rent(as % of GDP) in Coal?
Your answer should be compact. 0.25. What is the difference between the highest and the second highest Mineral Rent(as % of GDP) in Natural Gas?
Keep it short and to the point. 0.18. What is the difference between the highest and the second highest Mineral Rent(as % of GDP) in Oil?
Ensure brevity in your answer.  4.29. What is the difference between the highest and the second highest Mineral Rent(as % of GDP) of Other Minerals?
Keep it short and to the point. 0.04. What is the difference between the highest and the lowest Mineral Rent(as % of GDP) in Coal?
Your answer should be compact. 0.42. What is the difference between the highest and the lowest Mineral Rent(as % of GDP) of Natural Gas?
Your answer should be very brief. 1.15. What is the difference between the highest and the lowest Mineral Rent(as % of GDP) of Oil?
Your response must be concise. 17.23. What is the difference between the highest and the lowest Mineral Rent(as % of GDP) in Other Minerals?
Your answer should be very brief. 0.73. 